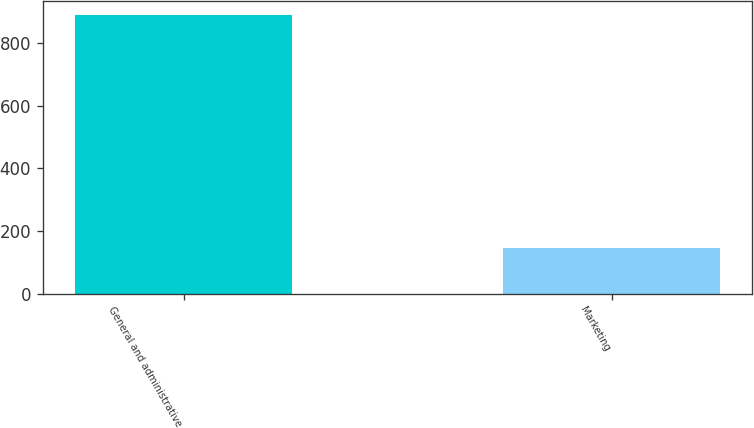Convert chart to OTSL. <chart><loc_0><loc_0><loc_500><loc_500><bar_chart><fcel>General and administrative<fcel>Marketing<nl><fcel>889<fcel>145<nl></chart> 